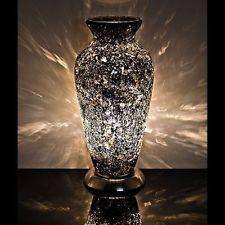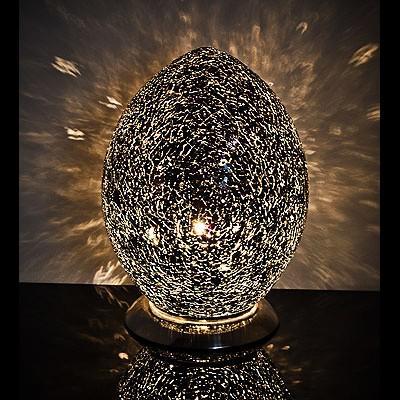The first image is the image on the left, the second image is the image on the right. Assess this claim about the two images: "In at least one image  there is a white and black speckled vase with a solid black top and bottom.". Correct or not? Answer yes or no. Yes. The first image is the image on the left, the second image is the image on the right. For the images displayed, is the sentence "One of the two vases is glowing yellow." factually correct? Answer yes or no. No. 